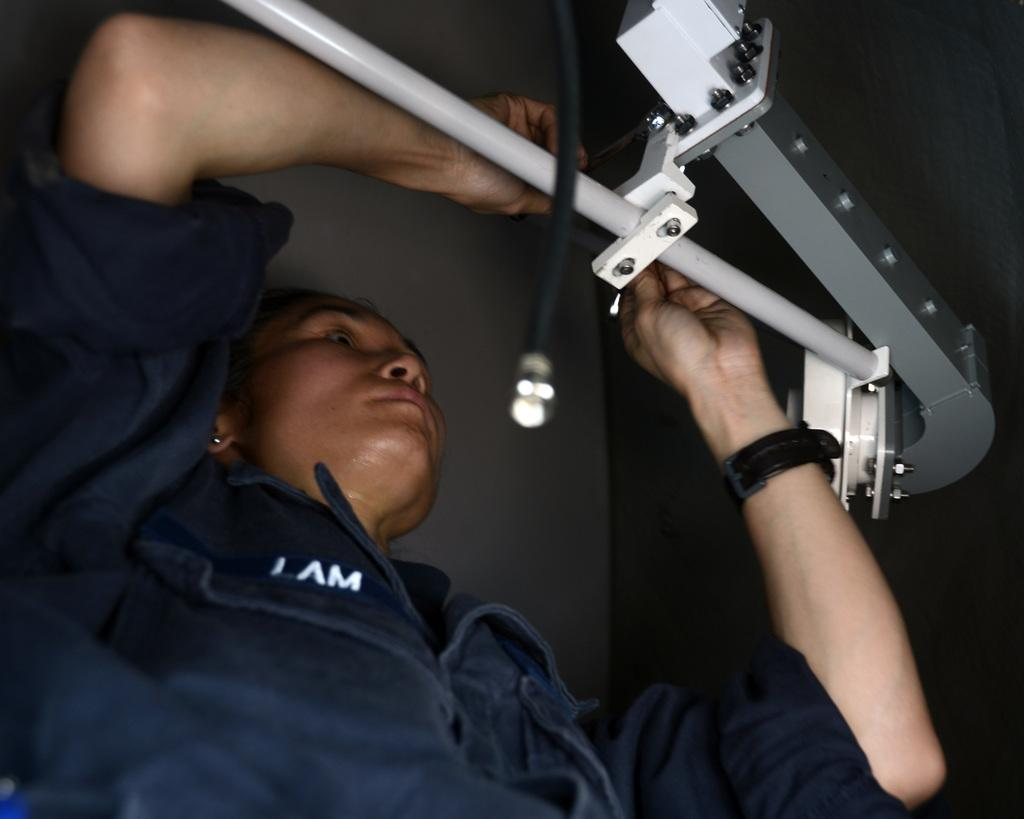Who is the main subject in the image? There is a woman in the image. What is the woman doing in the image? The woman is doing some work in the image. What tools or equipment is the woman using to do the work? The woman is using equipment to do the work. Are the boys having recess in the image? There is no mention of boys or recess in the image; it features a woman doing work. What type of glue is the woman using in the image? There is no glue present in the image; the woman is using equipment to do her work. 